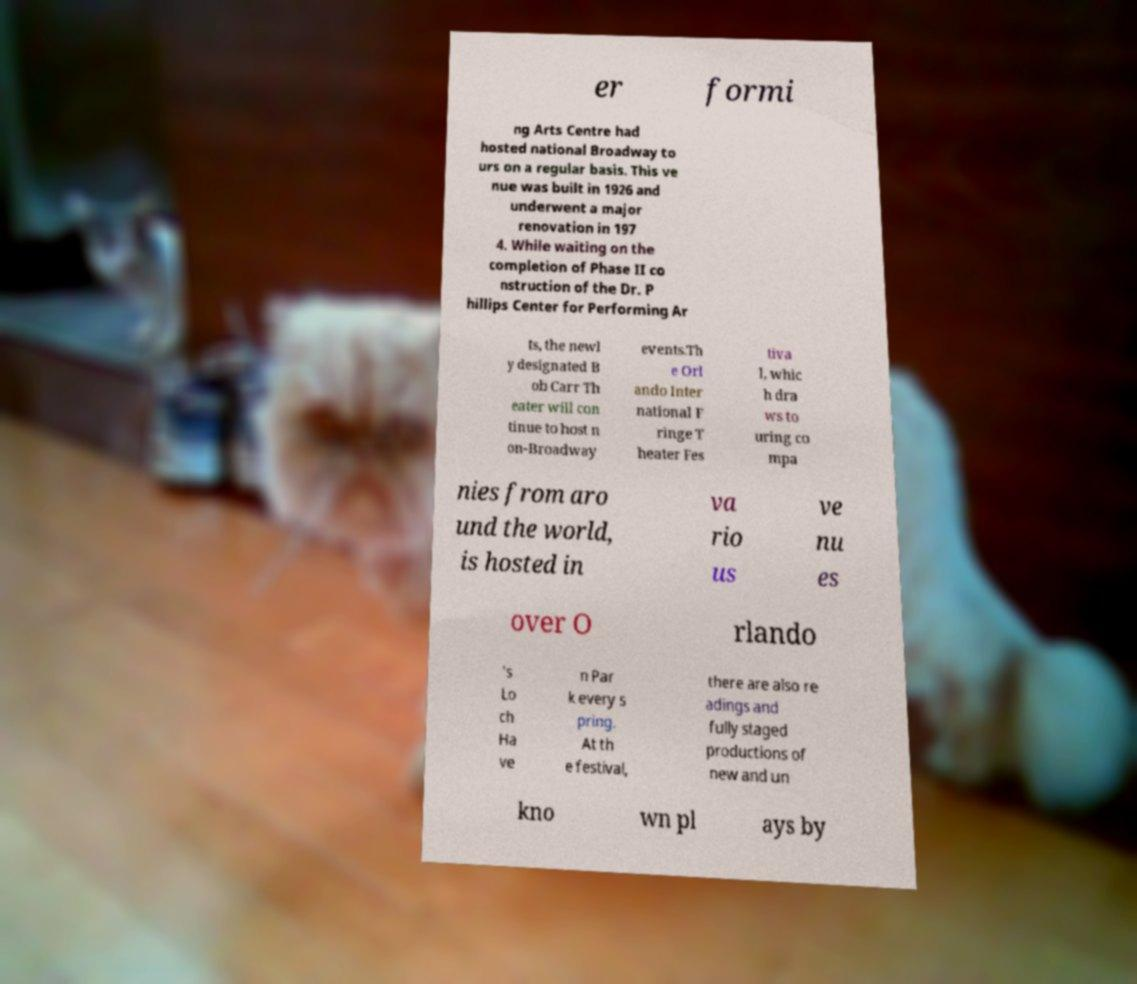Can you accurately transcribe the text from the provided image for me? er formi ng Arts Centre had hosted national Broadway to urs on a regular basis. This ve nue was built in 1926 and underwent a major renovation in 197 4. While waiting on the completion of Phase II co nstruction of the Dr. P hillips Center for Performing Ar ts, the newl y designated B ob Carr Th eater will con tinue to host n on-Broadway events.Th e Orl ando Inter national F ringe T heater Fes tiva l, whic h dra ws to uring co mpa nies from aro und the world, is hosted in va rio us ve nu es over O rlando 's Lo ch Ha ve n Par k every s pring. At th e festival, there are also re adings and fully staged productions of new and un kno wn pl ays by 